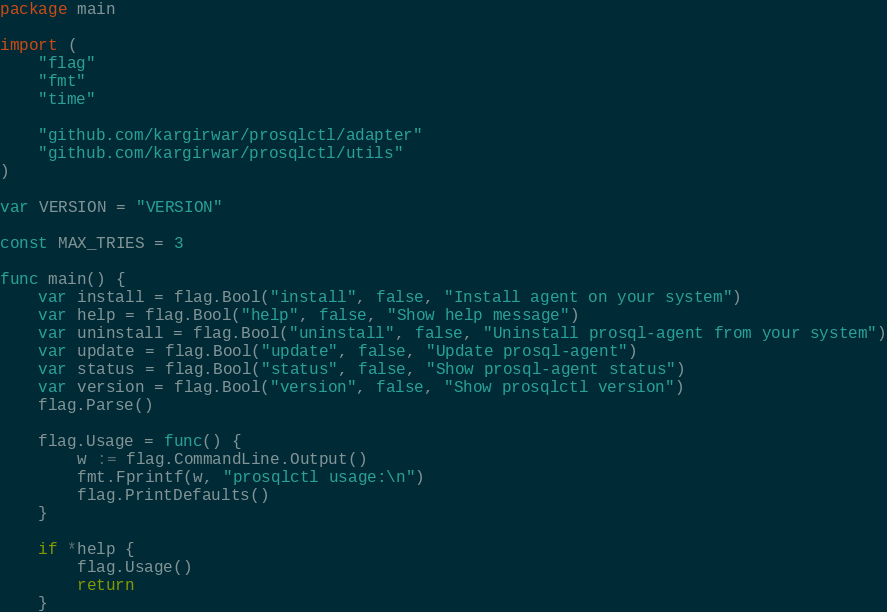Convert code to text. <code><loc_0><loc_0><loc_500><loc_500><_Go_>package main

import (
	"flag"
	"fmt"
	"time"

	"github.com/kargirwar/prosqlctl/adapter"
	"github.com/kargirwar/prosqlctl/utils"
)

var VERSION = "VERSION"

const MAX_TRIES = 3

func main() {
	var install = flag.Bool("install", false, "Install agent on your system")
	var help = flag.Bool("help", false, "Show help message")
	var uninstall = flag.Bool("uninstall", false, "Uninstall prosql-agent from your system")
	var update = flag.Bool("update", false, "Update prosql-agent")
	var status = flag.Bool("status", false, "Show prosql-agent status")
	var version = flag.Bool("version", false, "Show prosqlctl version")
	flag.Parse()

	flag.Usage = func() {
		w := flag.CommandLine.Output()
		fmt.Fprintf(w, "prosqlctl usage:\n")
		flag.PrintDefaults()
	}

	if *help {
		flag.Usage()
		return
	}
</code> 